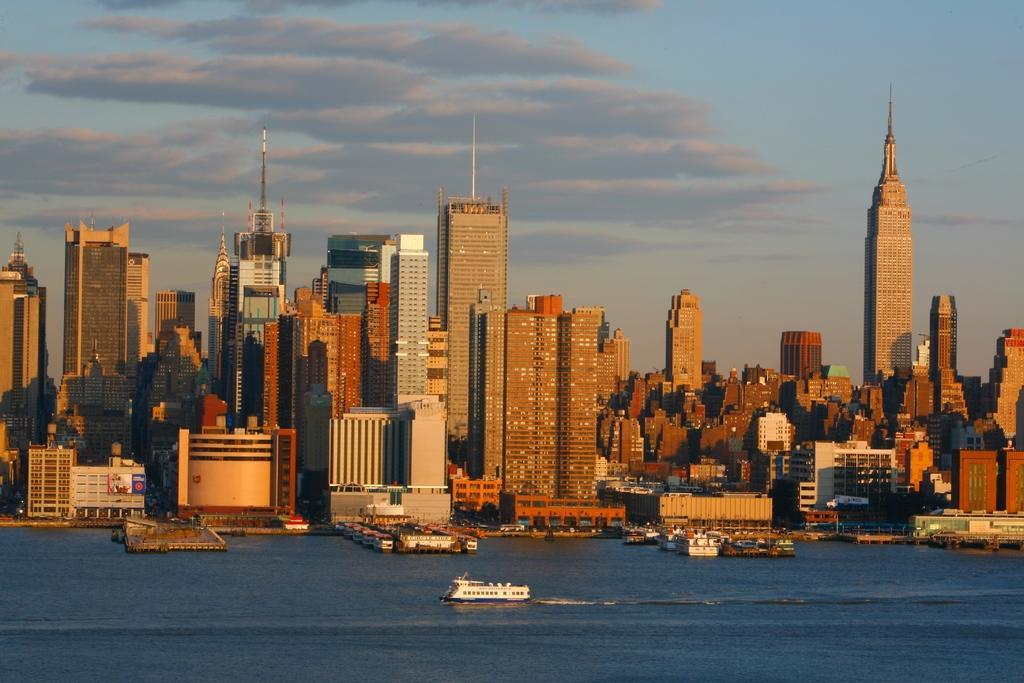Can you describe this image briefly? In this image I can see a boat on the water and the boat is in white color. Background I can see few building in brown and white color 